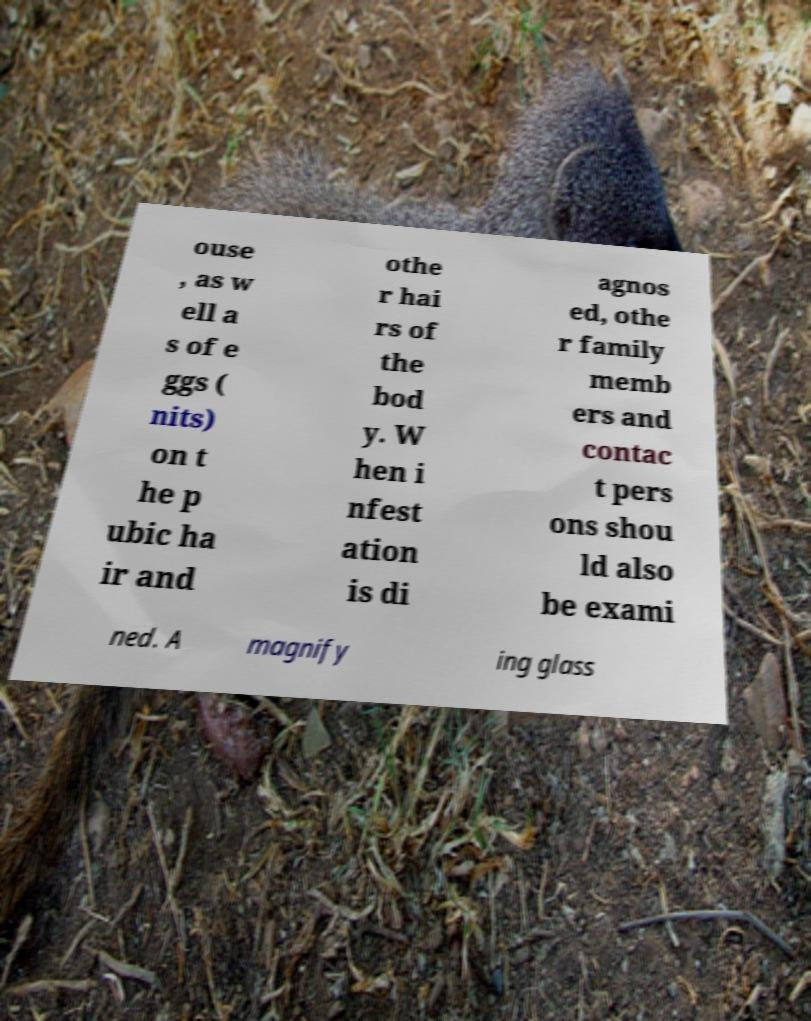Can you accurately transcribe the text from the provided image for me? ouse , as w ell a s of e ggs ( nits) on t he p ubic ha ir and othe r hai rs of the bod y. W hen i nfest ation is di agnos ed, othe r family memb ers and contac t pers ons shou ld also be exami ned. A magnify ing glass 